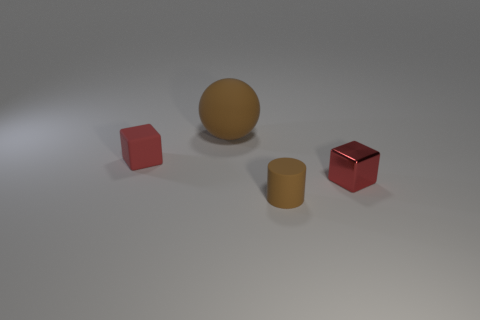What shapes are the objects in the image? The image contains four objects: two cubes, one sphere, and one cylinder. Each shape presents a different and distinct geometric form.  Could any of these objects fit inside each other? From the given perspective, it is difficult to determine if any of the objects could fit inside another, but based on their shapes and relative sizes, it's unlikely they are designed to nest within each other. 